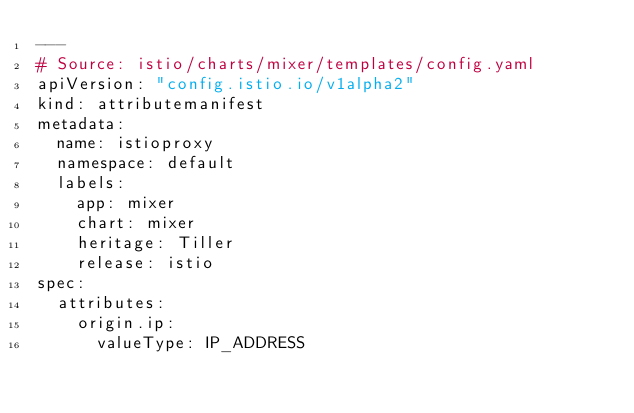<code> <loc_0><loc_0><loc_500><loc_500><_YAML_>---
# Source: istio/charts/mixer/templates/config.yaml
apiVersion: "config.istio.io/v1alpha2"
kind: attributemanifest
metadata:
  name: istioproxy
  namespace: default
  labels:
    app: mixer
    chart: mixer
    heritage: Tiller
    release: istio
spec:
  attributes:
    origin.ip:
      valueType: IP_ADDRESS</code> 